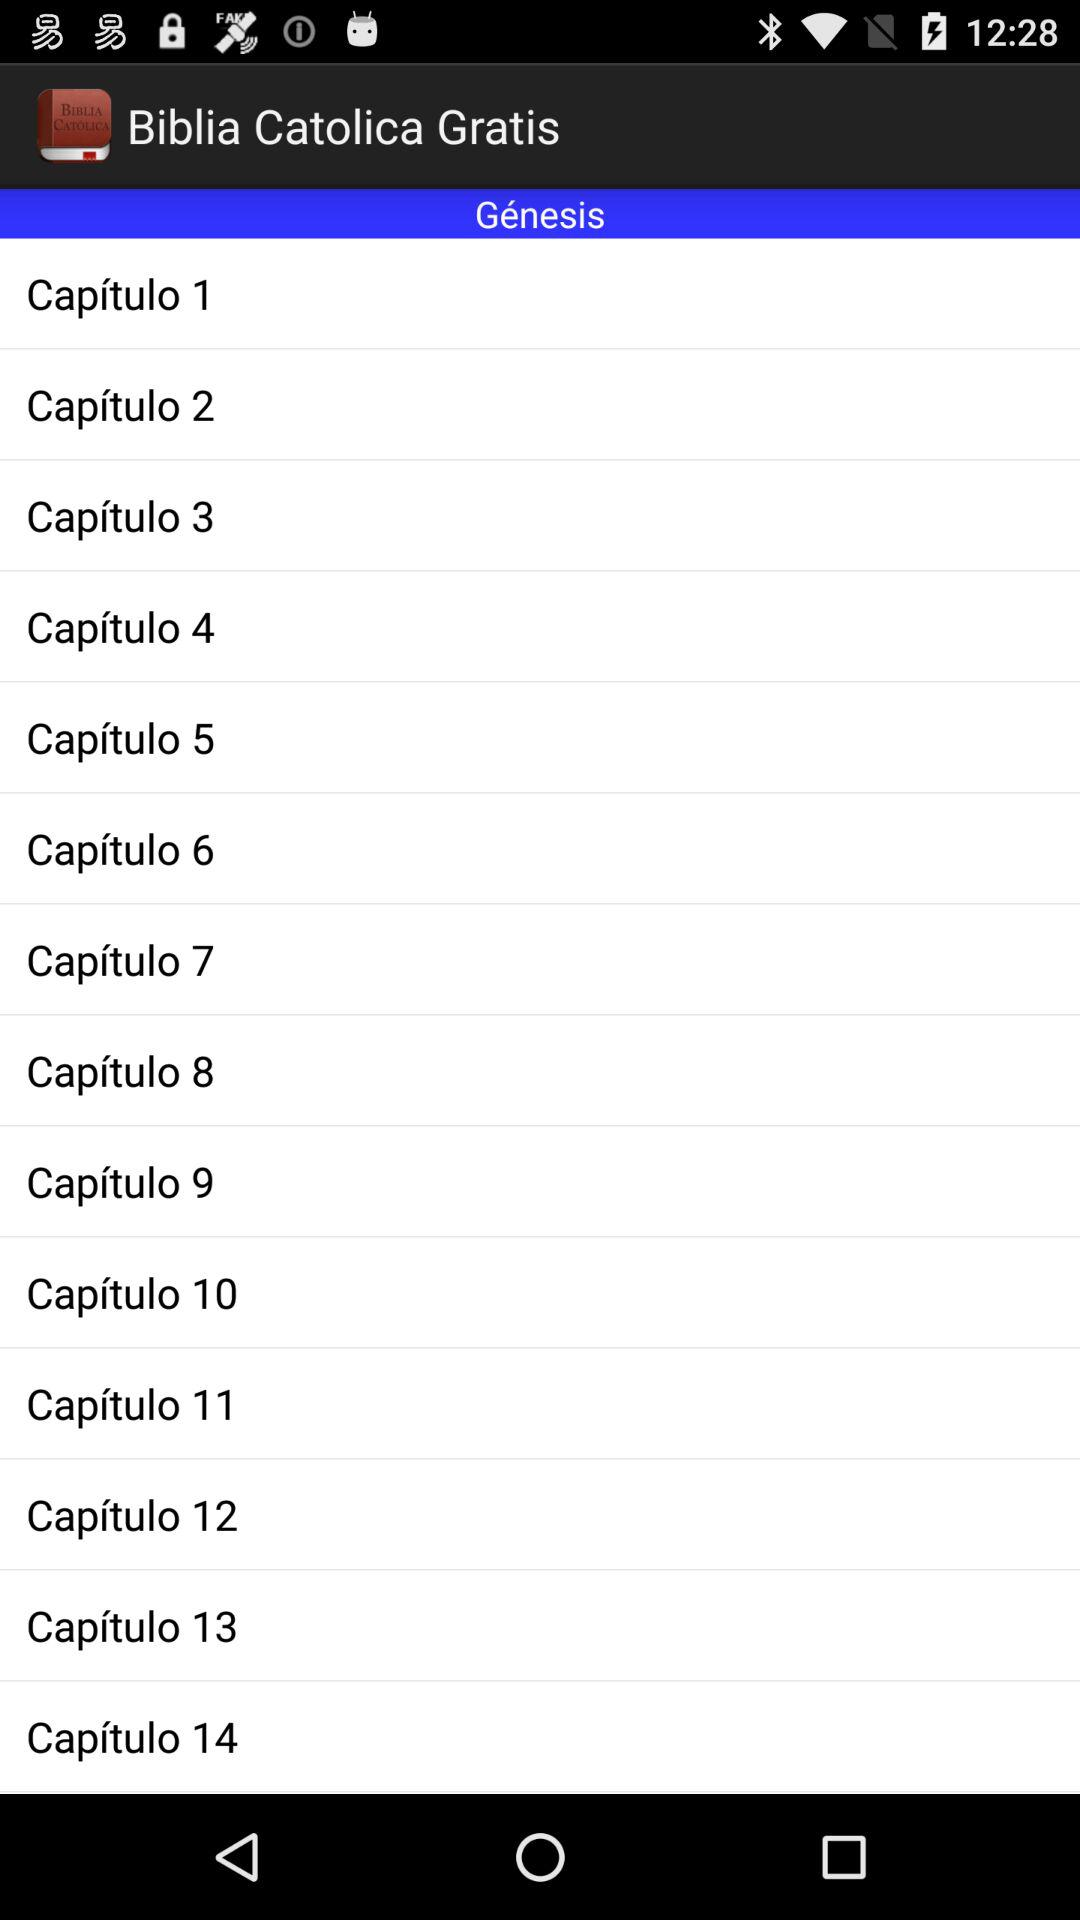How many chapters does the book of Genesis have?
Answer the question using a single word or phrase. 14 